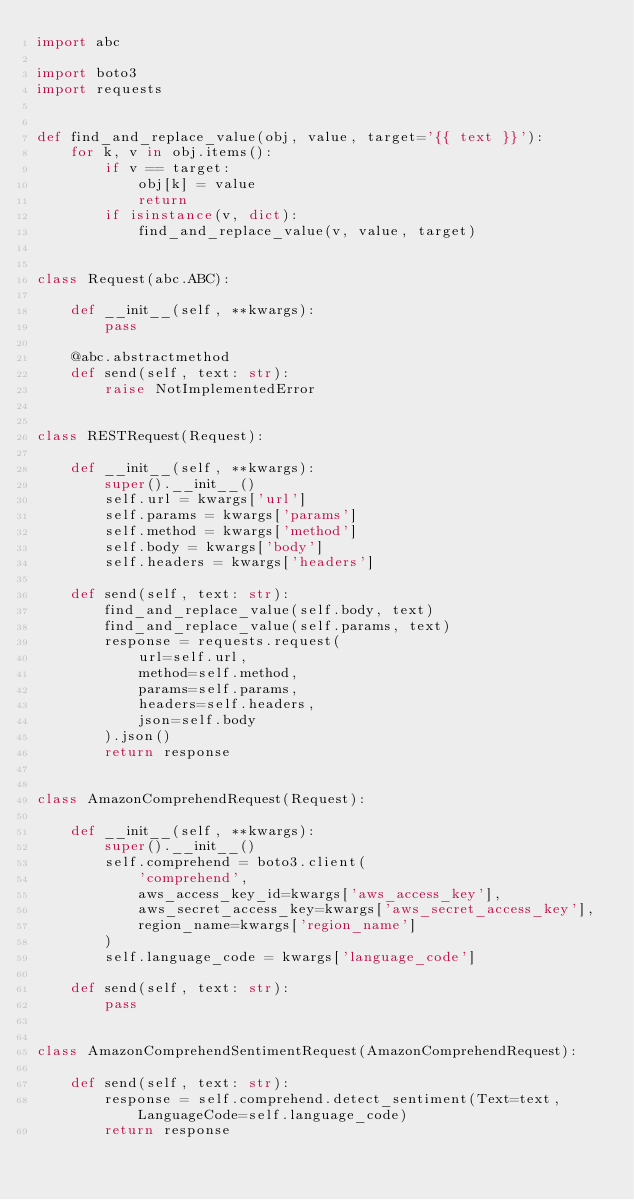Convert code to text. <code><loc_0><loc_0><loc_500><loc_500><_Python_>import abc

import boto3
import requests


def find_and_replace_value(obj, value, target='{{ text }}'):
    for k, v in obj.items():
        if v == target:
            obj[k] = value
            return
        if isinstance(v, dict):
            find_and_replace_value(v, value, target)


class Request(abc.ABC):

    def __init__(self, **kwargs):
        pass

    @abc.abstractmethod
    def send(self, text: str):
        raise NotImplementedError


class RESTRequest(Request):

    def __init__(self, **kwargs):
        super().__init__()
        self.url = kwargs['url']
        self.params = kwargs['params']
        self.method = kwargs['method']
        self.body = kwargs['body']
        self.headers = kwargs['headers']

    def send(self, text: str):
        find_and_replace_value(self.body, text)
        find_and_replace_value(self.params, text)
        response = requests.request(
            url=self.url,
            method=self.method,
            params=self.params,
            headers=self.headers,
            json=self.body
        ).json()
        return response


class AmazonComprehendRequest(Request):

    def __init__(self, **kwargs):
        super().__init__()
        self.comprehend = boto3.client(
            'comprehend',
            aws_access_key_id=kwargs['aws_access_key'],
            aws_secret_access_key=kwargs['aws_secret_access_key'],
            region_name=kwargs['region_name']
        )
        self.language_code = kwargs['language_code']

    def send(self, text: str):
        pass


class AmazonComprehendSentimentRequest(AmazonComprehendRequest):

    def send(self, text: str):
        response = self.comprehend.detect_sentiment(Text=text, LanguageCode=self.language_code)
        return response
</code> 